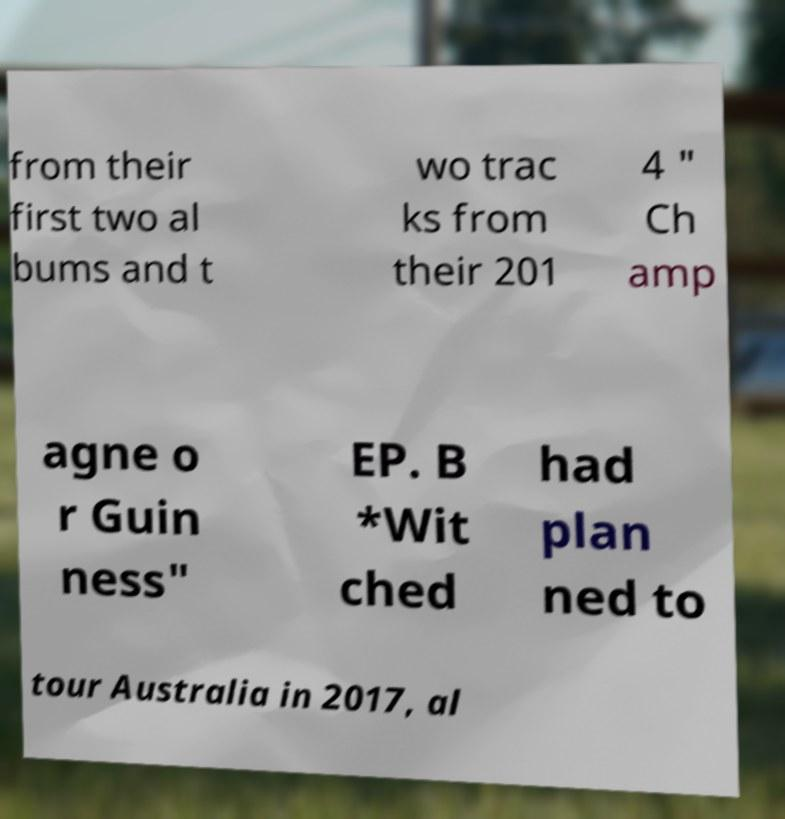Could you extract and type out the text from this image? from their first two al bums and t wo trac ks from their 201 4 " Ch amp agne o r Guin ness" EP. B *Wit ched had plan ned to tour Australia in 2017, al 